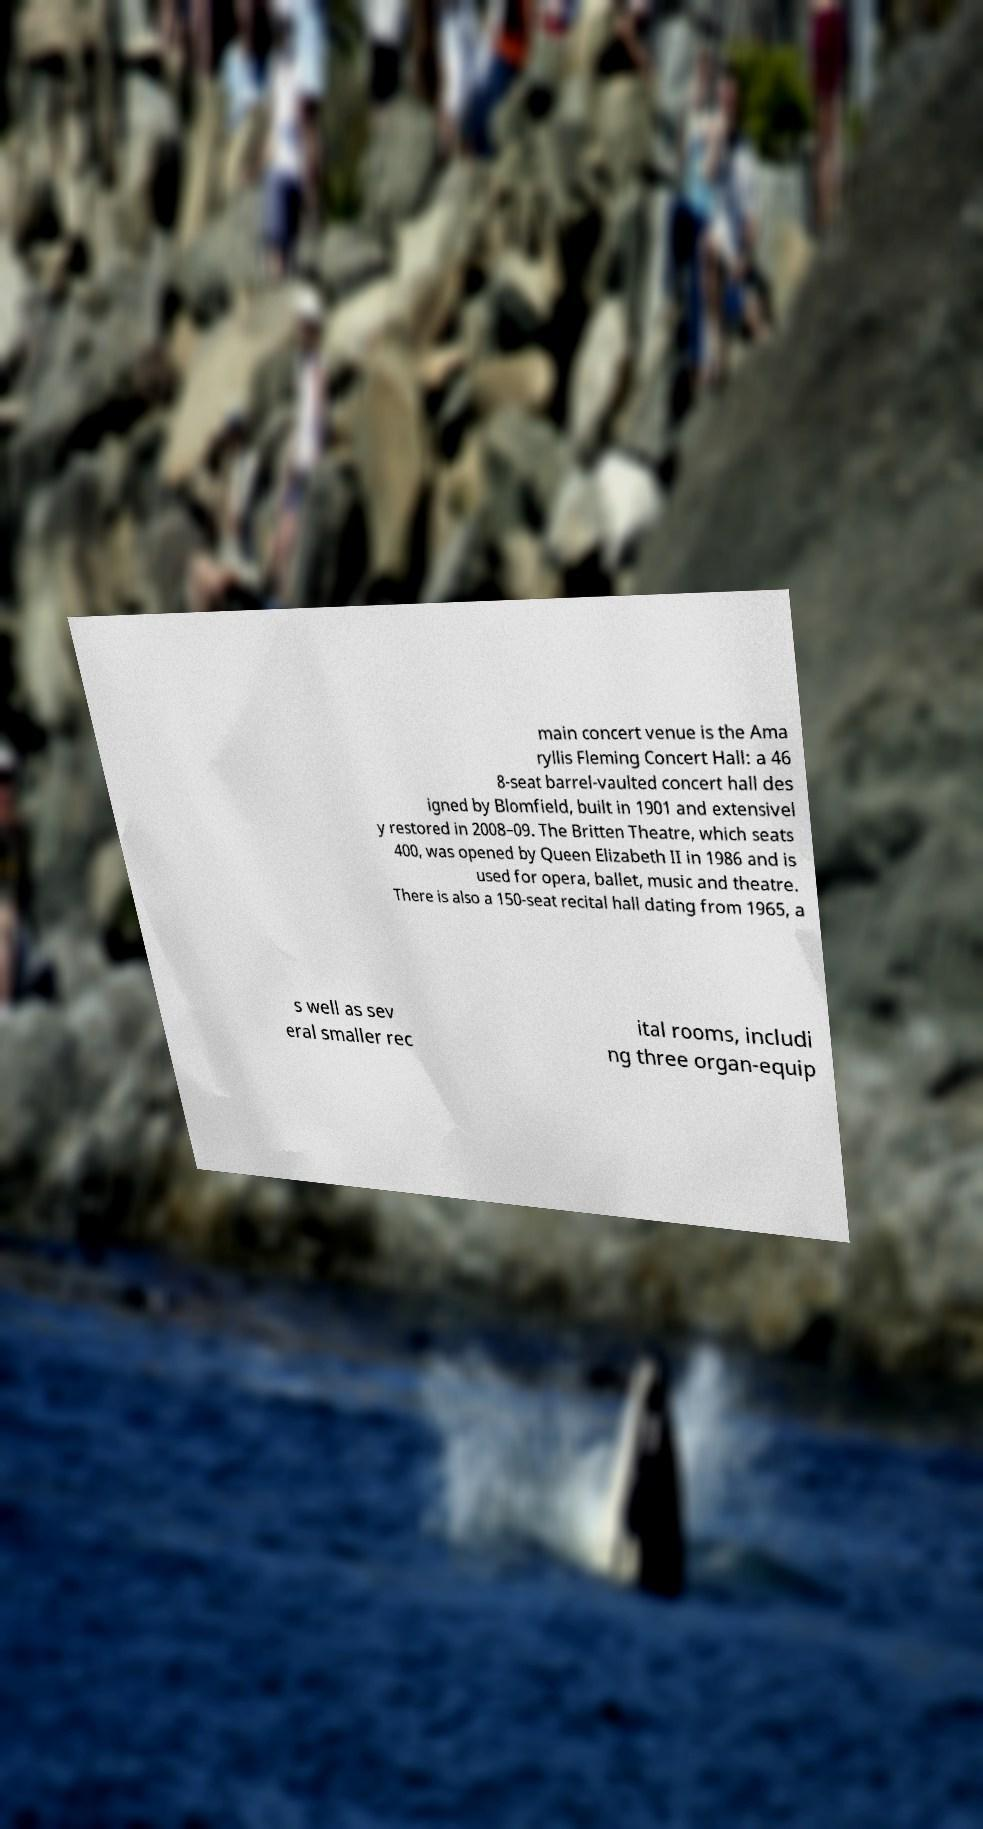What messages or text are displayed in this image? I need them in a readable, typed format. main concert venue is the Ama ryllis Fleming Concert Hall: a 46 8-seat barrel-vaulted concert hall des igned by Blomfield, built in 1901 and extensivel y restored in 2008–09. The Britten Theatre, which seats 400, was opened by Queen Elizabeth II in 1986 and is used for opera, ballet, music and theatre. There is also a 150-seat recital hall dating from 1965, a s well as sev eral smaller rec ital rooms, includi ng three organ-equip 